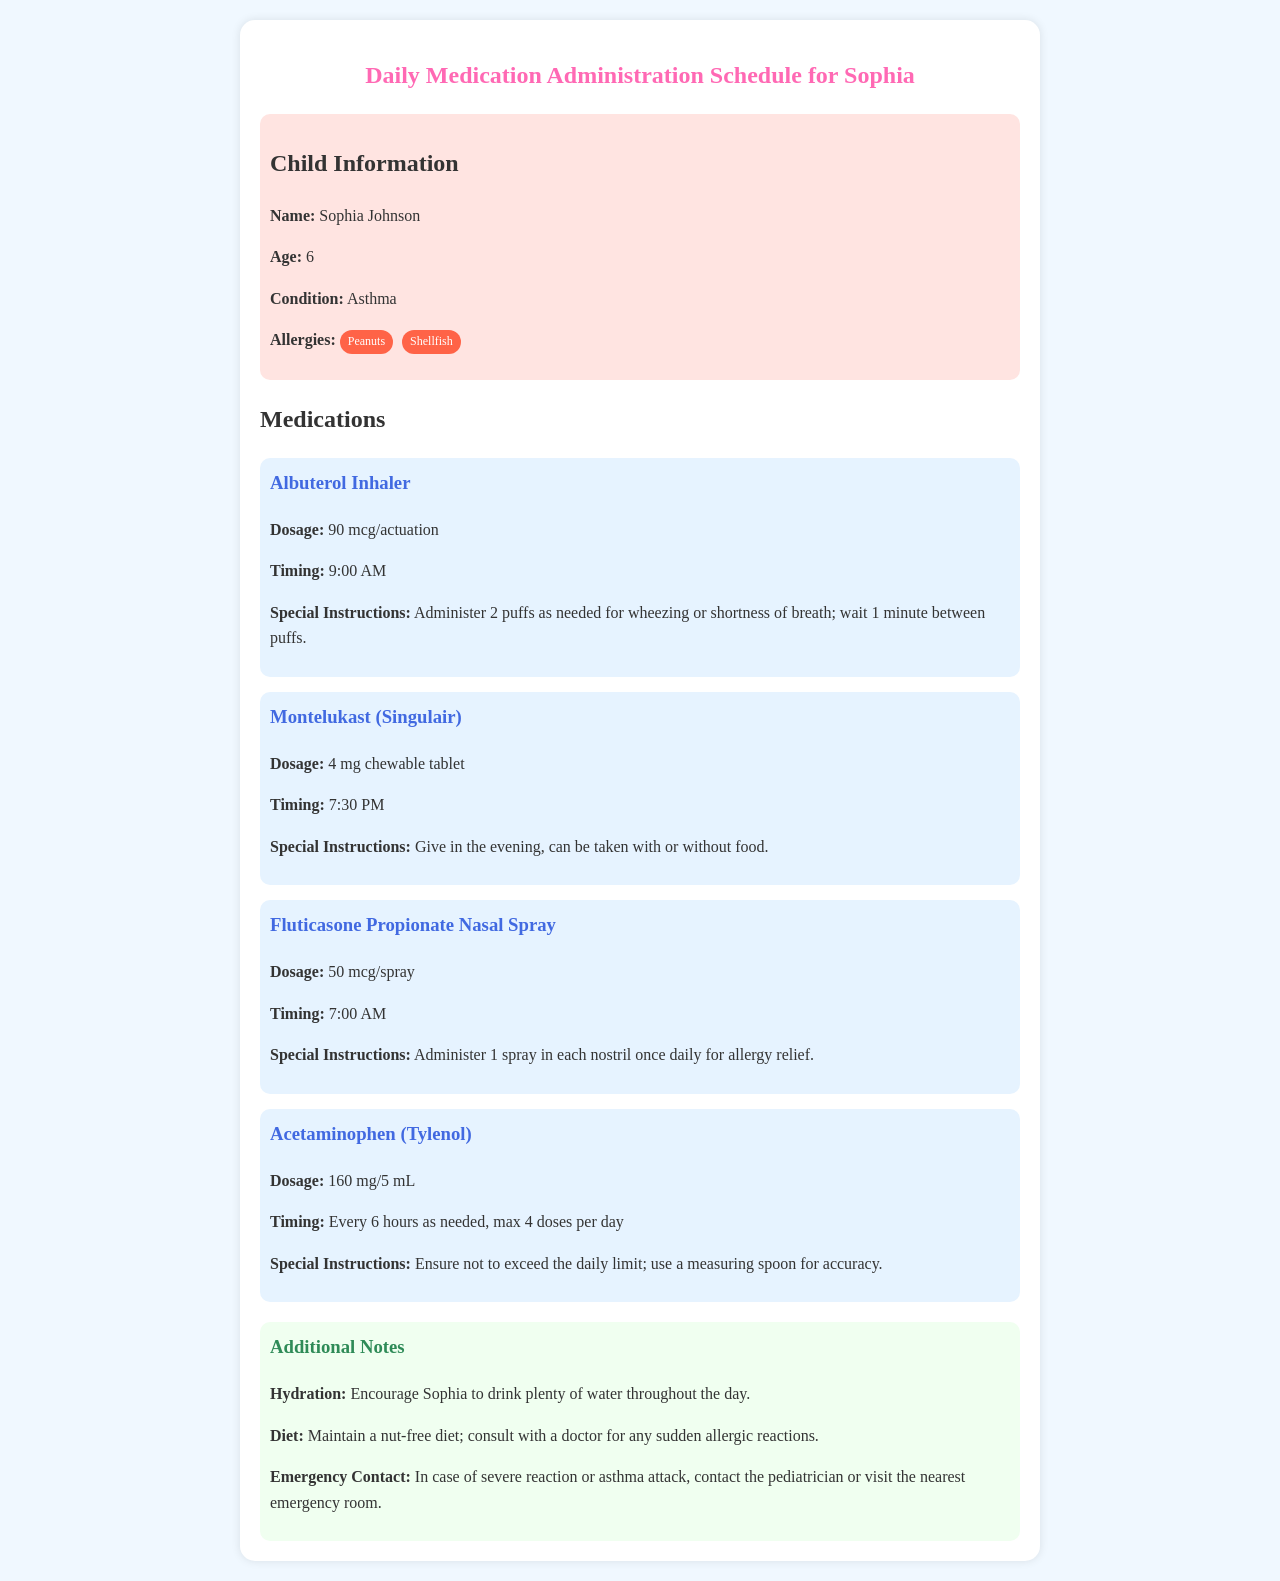What is Sophia's age? Sophia's age is mentioned in the child information section of the document.
Answer: 6 What condition does Sophia have? The document specifies Sophia's medical condition under child information.
Answer: Asthma What is the dosage for Albuterol Inhaler? The dosage for Albuterol Inhaler is detailed in the medications section of the document.
Answer: 90 mcg/actuation At what time should Montelukast be administered? The timing for Montelukast is provided in the medications section of the document.
Answer: 7:30 PM How many doses of Acetaminophen can Sophia have in a day? The maximum number of doses per day for Acetaminophen is listed in the medications section.
Answer: 4 doses What special instruction is given for Fluticasone Propionate Nasal Spray? The specific instruction for Fluticasone is provided under its medication section.
Answer: Administer 1 spray in each nostril once daily for allergy relief What is the allergy tag associated with Sophia? The document highlights Sophia's allergies in the child information section.
Answer: Peanuts, Shellfish What should be encouraged for Sophia throughout the day? The additional notes section mentions what should be encouraged for Sophia's well-being.
Answer: Hydration What is the special instruction for Acetaminophen dosage? The special instruction regarding the administration of Acetaminophen can be found in its medication description.
Answer: Use a measuring spoon for accuracy 